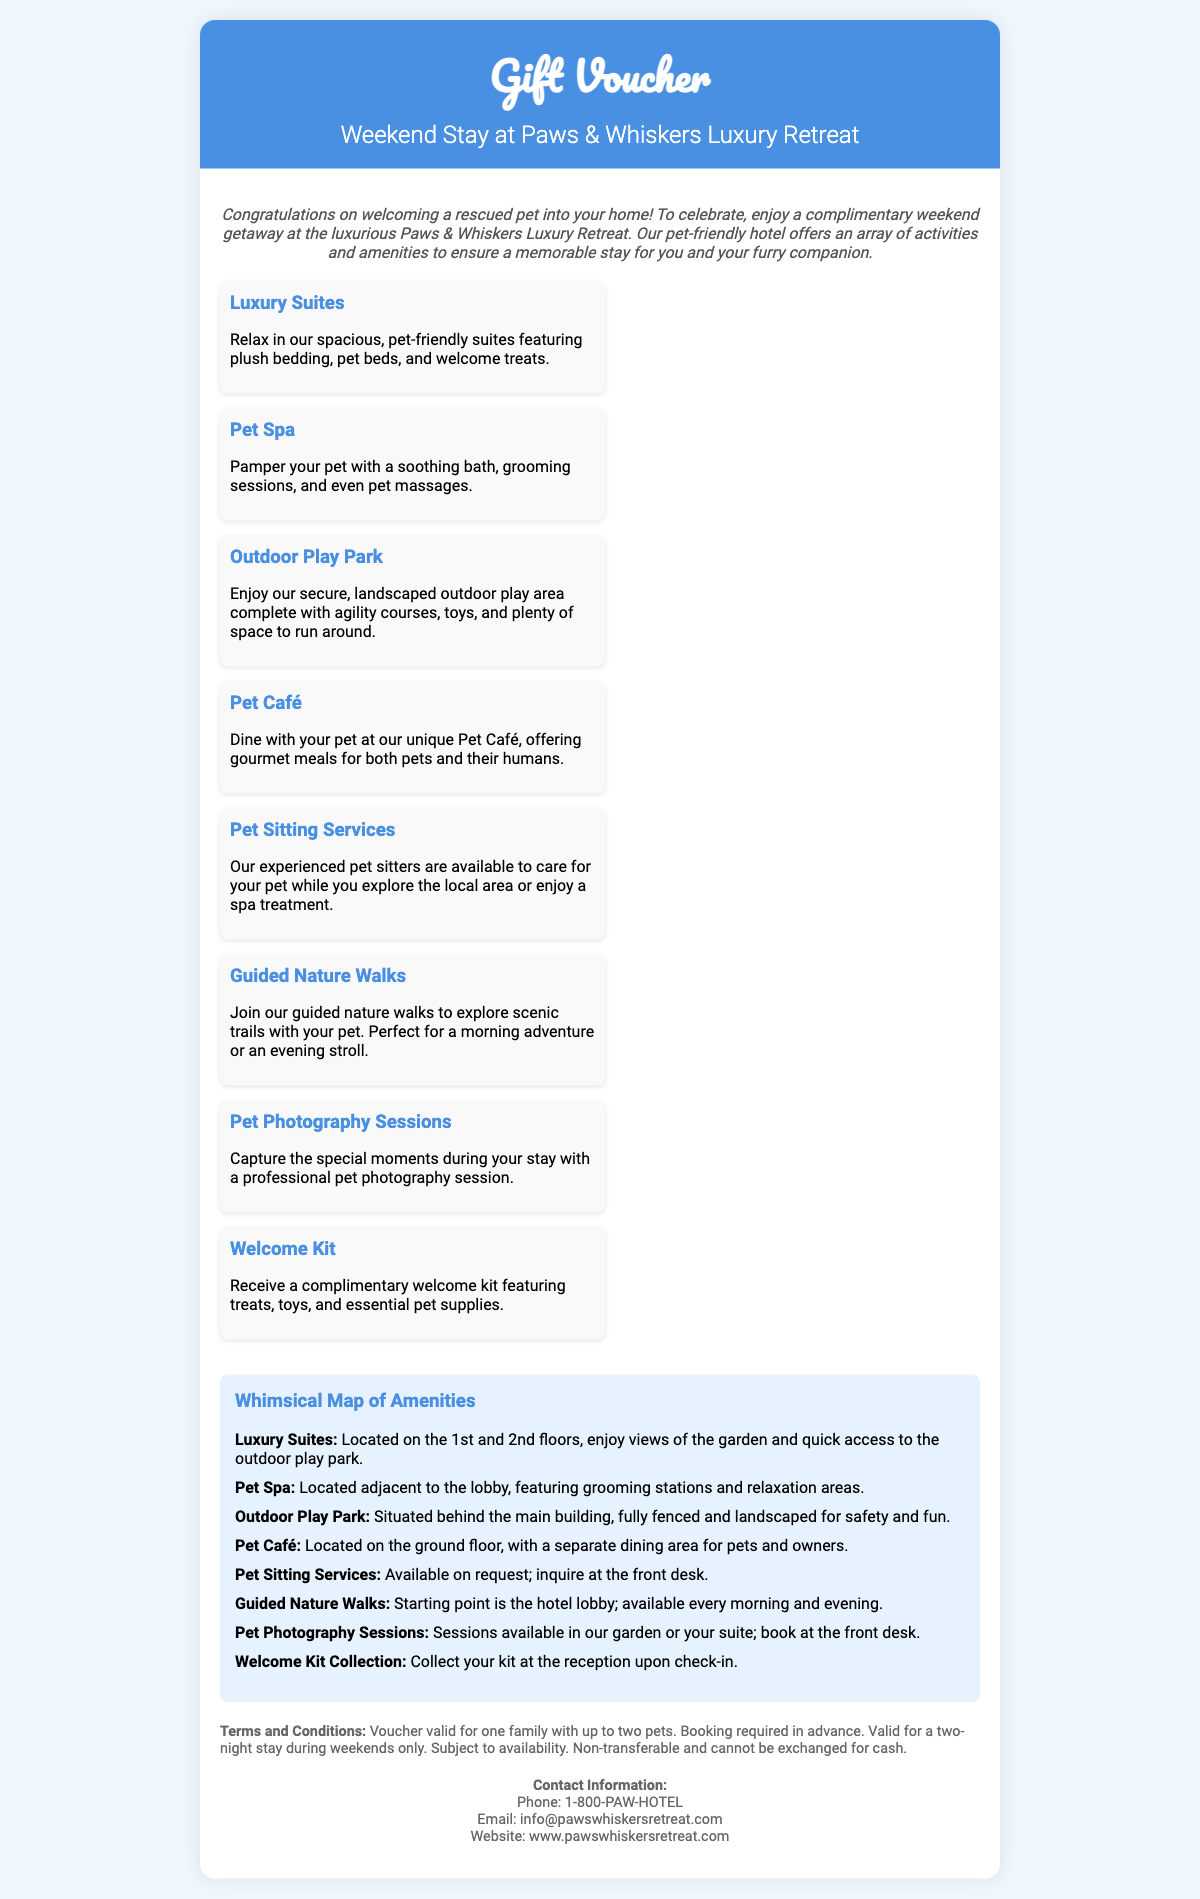What is the name of the hotel? The hotel is named "Paws & Whiskers Luxury Retreat," as stated in the title of the voucher.
Answer: Paws & Whiskers Luxury Retreat What type of stay does the voucher cover? The voucher covers a weekend stay, as mentioned in the description.
Answer: Weekend stay How many pets can accompany a family? The terms state that the voucher is valid for one family with up to two pets.
Answer: Two pets What service is available to pamper pets? The amenities list includes a "Pet Spa," where pets can receive grooming and massages.
Answer: Pet Spa Where is the Pet Café located? The hotel map indicates that the Pet Café is located on the ground floor.
Answer: Ground floor What is included in the welcome kit? The welcome kit features treats, toys, and essential pet supplies, as described in the amenities section.
Answer: Treats, toys, and essential pet supplies Where can guests collect their welcome kit? Guests can collect their welcome kit at the reception upon check-in, as specified in the whimsical map section.
Answer: Reception What are the contact details for the hotel? The voucher provides a phone number, email, and website for contacting the hotel.
Answer: Phone: 1-800-PAW-HOTEL, Email: info@pawswhiskersretreat.com, Website: www.pawswhiskersretreat.com What is required for booking the stay? The terms and conditions specify that booking is required in advance.
Answer: Booking required in advance 